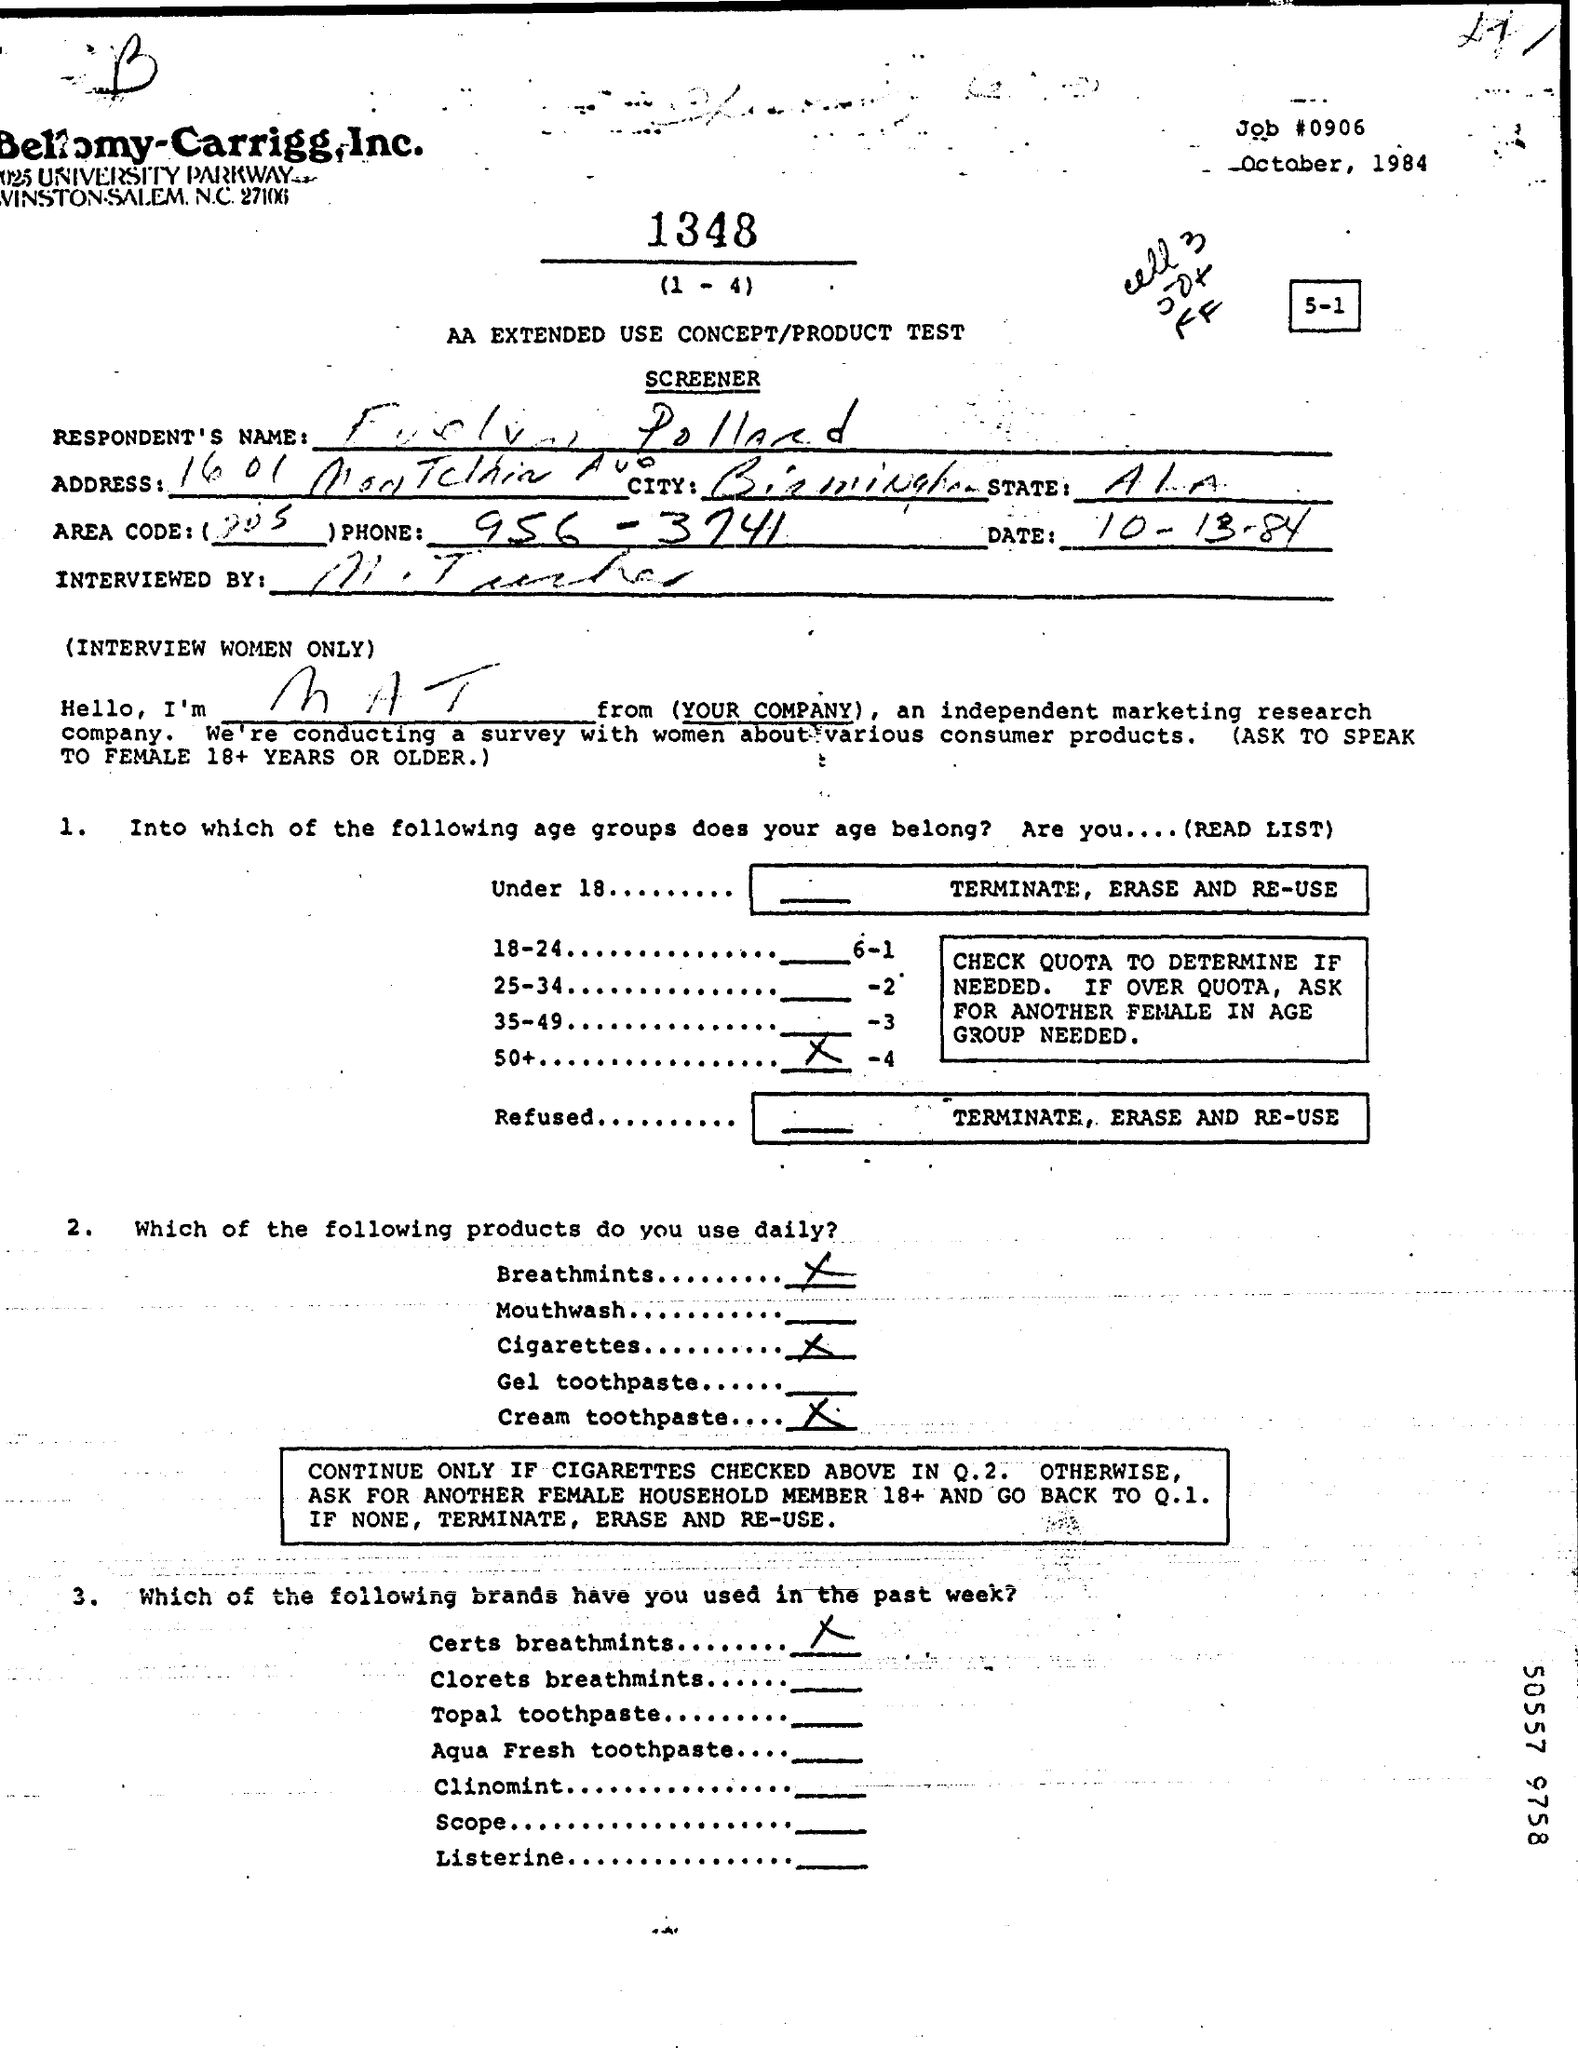Indicate a few pertinent items in this graphic. The date is October 13th, 1984. The Job# is 0906. The phone number is 956-3741. 